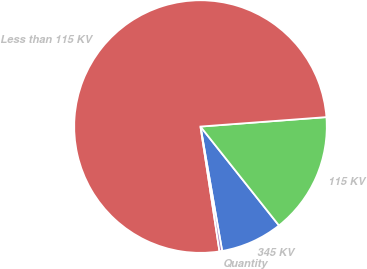<chart> <loc_0><loc_0><loc_500><loc_500><pie_chart><fcel>345 KV<fcel>115 KV<fcel>Less than 115 KV<fcel>Quantity<nl><fcel>7.93%<fcel>15.52%<fcel>76.21%<fcel>0.34%<nl></chart> 